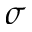Convert formula to latex. <formula><loc_0><loc_0><loc_500><loc_500>\sigma</formula> 